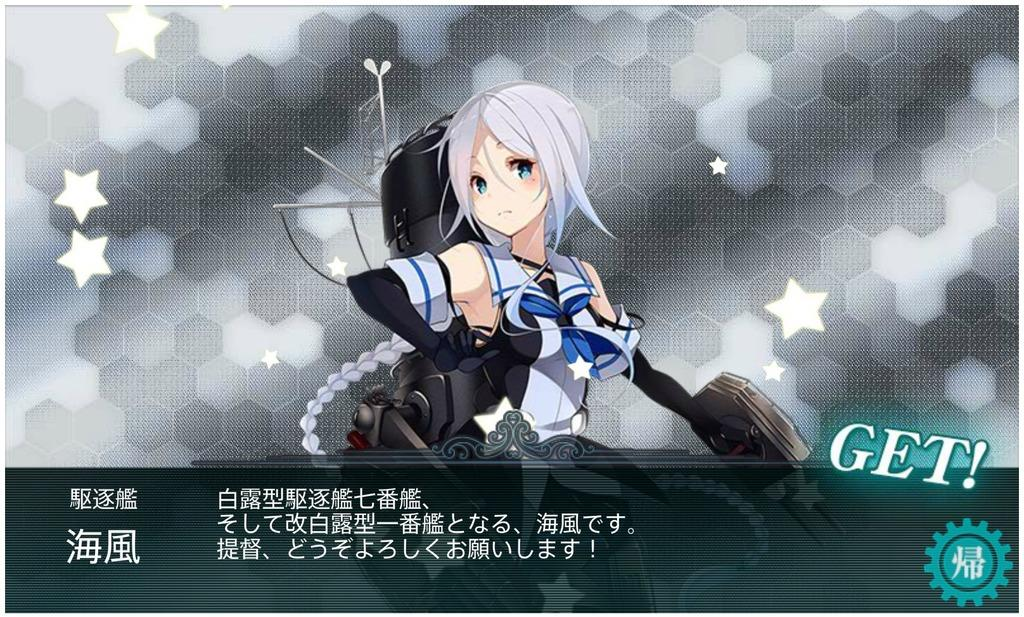What type of image is being described? The image is animated. Who is the main subject in the image? There is a girl in the center of the image. What is the girl wearing? The girl is wearing a bag. What additional information can be found at the bottom of the image? There is text printed at the bottom of the image. What type of songs can be heard playing in the background of the image? There is no audio or music present in the image, as it is a still image. What kind of apparatus is being used by the girl in the image? There is no apparatus visible in the image; the girl is simply standing and wearing a bag. 